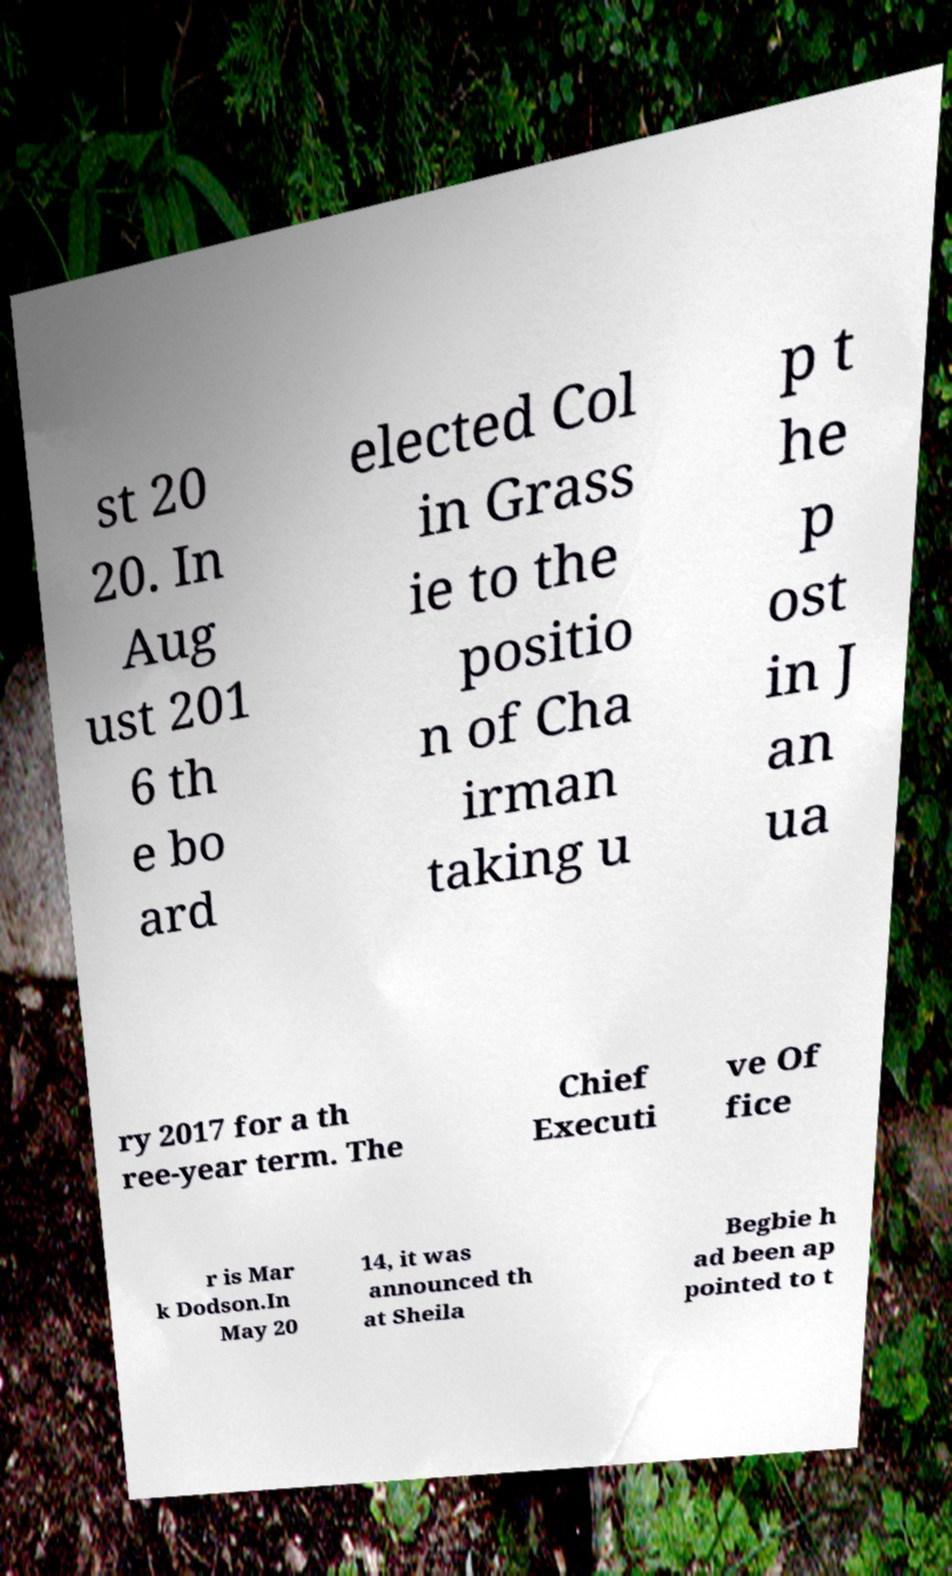What messages or text are displayed in this image? I need them in a readable, typed format. st 20 20. In Aug ust 201 6 th e bo ard elected Col in Grass ie to the positio n of Cha irman taking u p t he p ost in J an ua ry 2017 for a th ree-year term. The Chief Executi ve Of fice r is Mar k Dodson.In May 20 14, it was announced th at Sheila Begbie h ad been ap pointed to t 